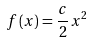Convert formula to latex. <formula><loc_0><loc_0><loc_500><loc_500>f \left ( x \right ) = \frac { c } { 2 } x ^ { 2 }</formula> 